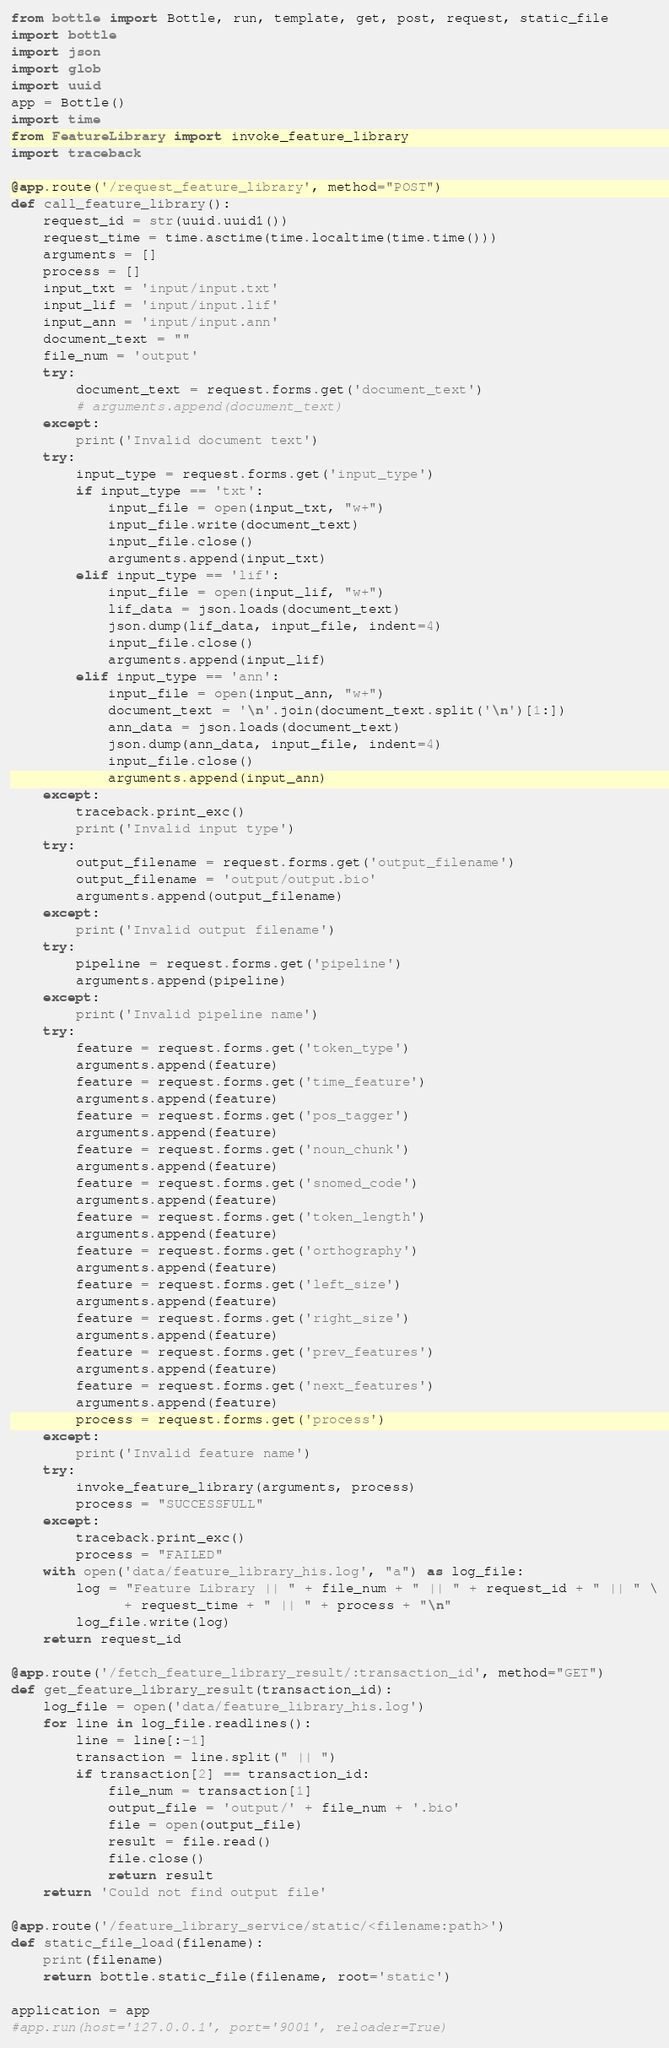<code> <loc_0><loc_0><loc_500><loc_500><_Python_>from bottle import Bottle, run, template, get, post, request, static_file
import bottle
import json
import glob
import uuid
app = Bottle()
import time
from FeatureLibrary import invoke_feature_library
import traceback

@app.route('/request_feature_library', method="POST")
def call_feature_library():
    request_id = str(uuid.uuid1())
    request_time = time.asctime(time.localtime(time.time()))
    arguments = []
    process = []
    input_txt = 'input/input.txt'
    input_lif = 'input/input.lif'
    input_ann = 'input/input.ann'
    document_text = ""
    file_num = 'output'
    try:
        document_text = request.forms.get('document_text')
        # arguments.append(document_text)
    except:
        print('Invalid document text')
    try:
        input_type = request.forms.get('input_type')
        if input_type == 'txt':
            input_file = open(input_txt, "w+")
            input_file.write(document_text)
            input_file.close()
            arguments.append(input_txt)
        elif input_type == 'lif':
            input_file = open(input_lif, "w+")
            lif_data = json.loads(document_text)
            json.dump(lif_data, input_file, indent=4)
            input_file.close()
            arguments.append(input_lif)
        elif input_type == 'ann':
            input_file = open(input_ann, "w+")
            document_text = '\n'.join(document_text.split('\n')[1:])
            ann_data = json.loads(document_text)
            json.dump(ann_data, input_file, indent=4)
            input_file.close()
            arguments.append(input_ann)
    except:
        traceback.print_exc()
        print('Invalid input type')
    try:
        output_filename = request.forms.get('output_filename')
        output_filename = 'output/output.bio'
        arguments.append(output_filename)
    except:
        print('Invalid output filename')
    try:
        pipeline = request.forms.get('pipeline')
        arguments.append(pipeline)
    except:
        print('Invalid pipeline name')
    try:
        feature = request.forms.get('token_type')
        arguments.append(feature)
        feature = request.forms.get('time_feature')
        arguments.append(feature)
        feature = request.forms.get('pos_tagger')
        arguments.append(feature)
        feature = request.forms.get('noun_chunk')
        arguments.append(feature)
        feature = request.forms.get('snomed_code')
        arguments.append(feature)
        feature = request.forms.get('token_length')
        arguments.append(feature)
        feature = request.forms.get('orthography')
        arguments.append(feature)
        feature = request.forms.get('left_size')
        arguments.append(feature)
        feature = request.forms.get('right_size')
        arguments.append(feature)
        feature = request.forms.get('prev_features')
        arguments.append(feature)
        feature = request.forms.get('next_features')
        arguments.append(feature)
        process = request.forms.get('process')
    except:
        print('Invalid feature name')
    try:
        invoke_feature_library(arguments, process)
        process = "SUCCESSFULL"
    except:
        traceback.print_exc()
        process = "FAILED"
    with open('data/feature_library_his.log', "a") as log_file:
        log = "Feature Library || " + file_num + " || " + request_id + " || " \
              + request_time + " || " + process + "\n"
        log_file.write(log)
    return request_id

@app.route('/fetch_feature_library_result/:transaction_id', method="GET")
def get_feature_library_result(transaction_id):
    log_file = open('data/feature_library_his.log')
    for line in log_file.readlines():
        line = line[:-1]
        transaction = line.split(" || ")
        if transaction[2] == transaction_id:
            file_num = transaction[1]
            output_file = 'output/' + file_num + '.bio'
            file = open(output_file)
            result = file.read()
            file.close()
            return result
    return 'Could not find output file'

@app.route('/feature_library_service/static/<filename:path>')
def static_file_load(filename):
    print(filename)
    return bottle.static_file(filename, root='static')

application = app
#app.run(host='127.0.0.1', port='9001', reloader=True)</code> 